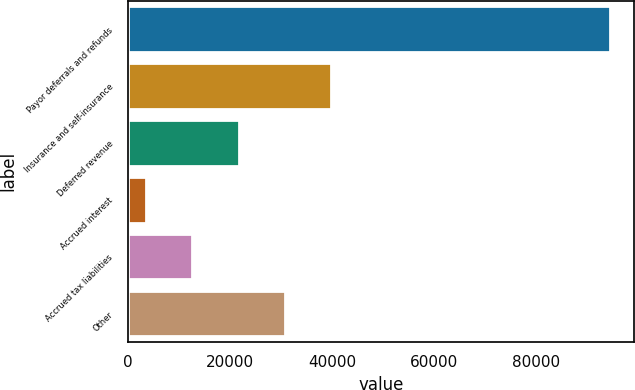Convert chart to OTSL. <chart><loc_0><loc_0><loc_500><loc_500><bar_chart><fcel>Payor deferrals and refunds<fcel>Insurance and self-insurance<fcel>Deferred revenue<fcel>Accrued interest<fcel>Accrued tax liabilities<fcel>Other<nl><fcel>94566<fcel>39900.6<fcel>21678.8<fcel>3457<fcel>12567.9<fcel>30789.7<nl></chart> 